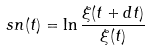<formula> <loc_0><loc_0><loc_500><loc_500>s n ( t ) = \ln { \frac { \xi ( t + d t ) } { \xi ( t ) } }</formula> 